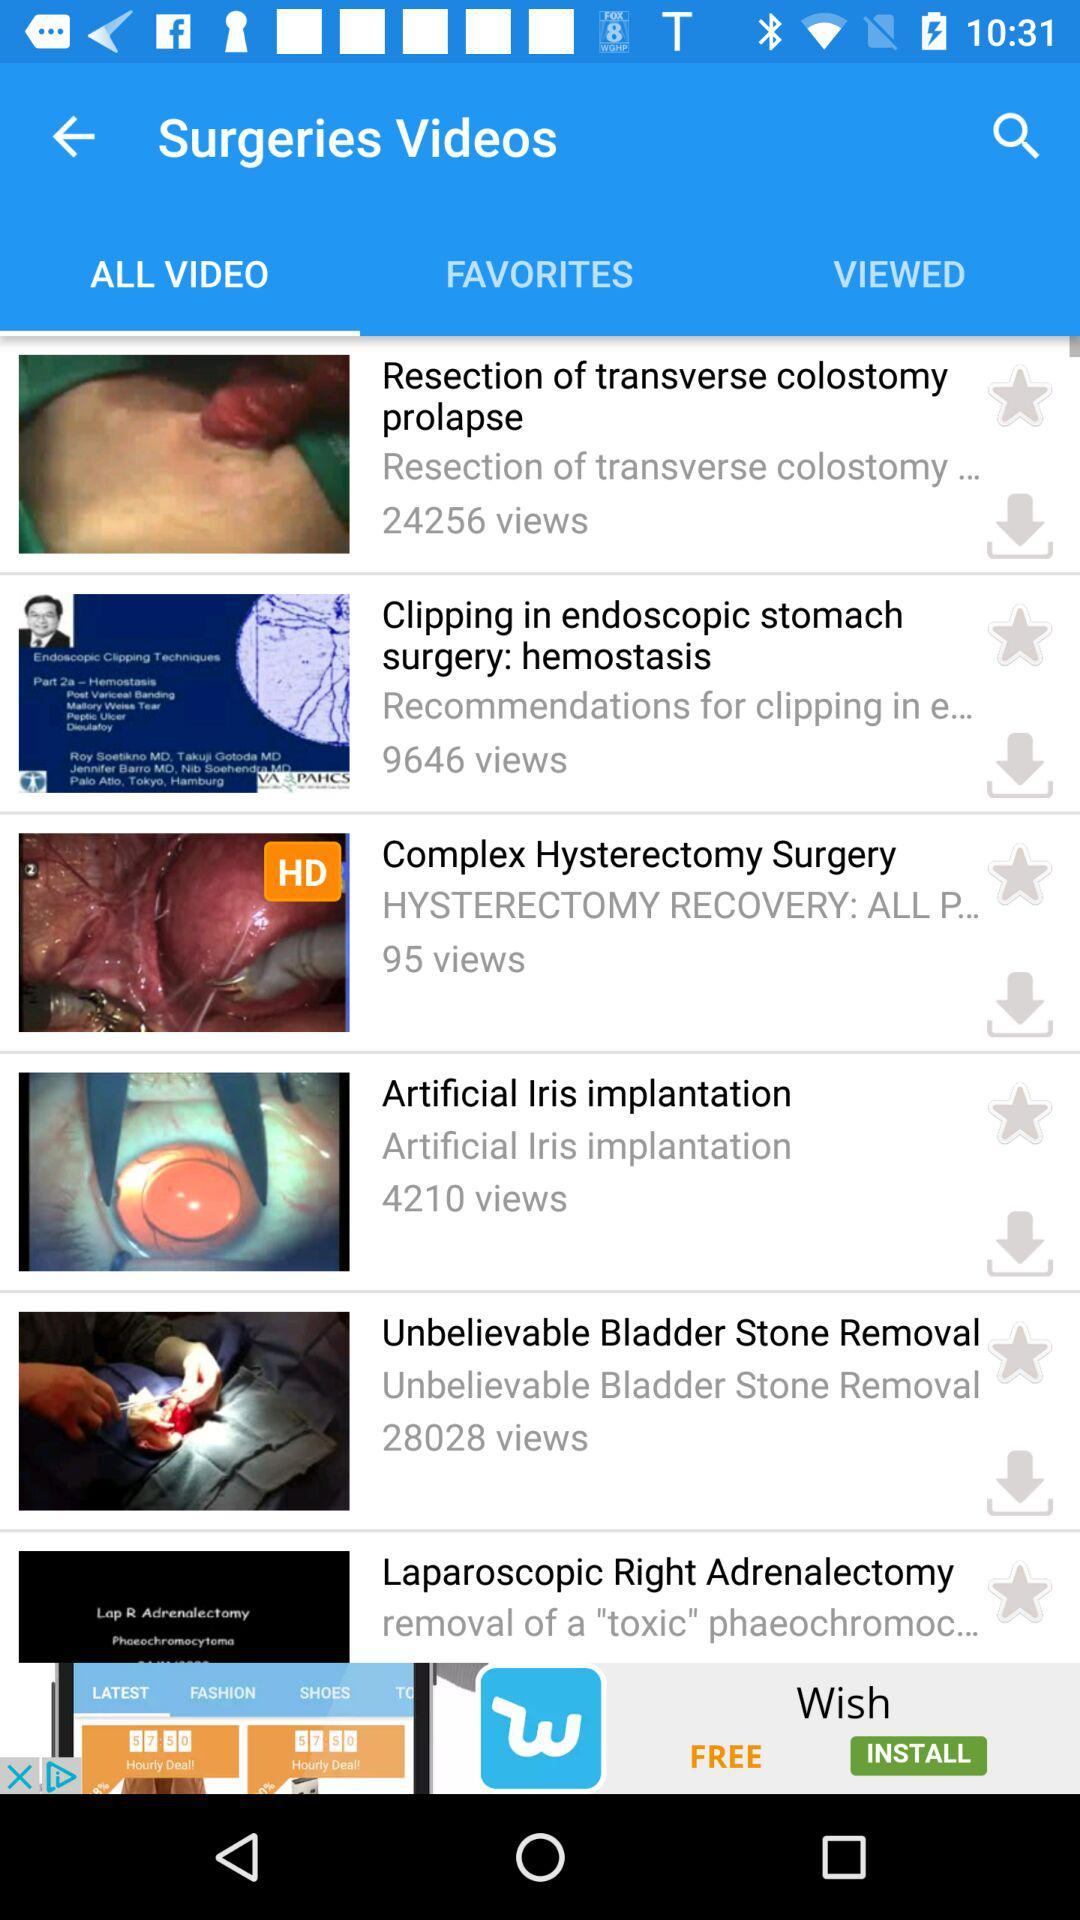Which option is selected? The selected option is "ALL VIDEO". 